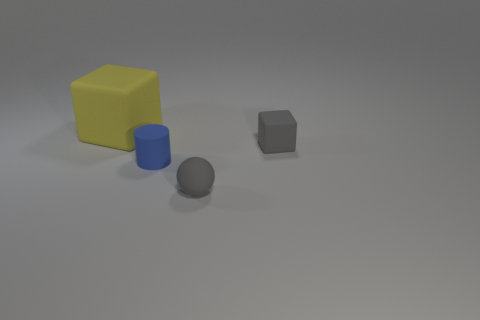What material is the block that is the same size as the rubber ball?
Keep it short and to the point. Rubber. There is a tiny gray thing that is in front of the blue rubber thing; is it the same shape as the yellow object?
Offer a terse response. No. Are there more gray spheres in front of the ball than blue cylinders that are on the left side of the tiny gray cube?
Your answer should be very brief. No. How many gray blocks are made of the same material as the blue cylinder?
Make the answer very short. 1. Is the size of the gray block the same as the blue matte thing?
Provide a short and direct response. Yes. What is the color of the small rubber cylinder?
Your answer should be very brief. Blue. What number of things are either small green rubber cubes or big yellow things?
Offer a terse response. 1. Is there a brown shiny object of the same shape as the big yellow matte thing?
Your answer should be very brief. No. Is the color of the small object that is behind the blue cylinder the same as the tiny rubber sphere?
Provide a short and direct response. Yes. What shape is the small gray matte thing in front of the cube in front of the big rubber cube?
Your answer should be compact. Sphere. 